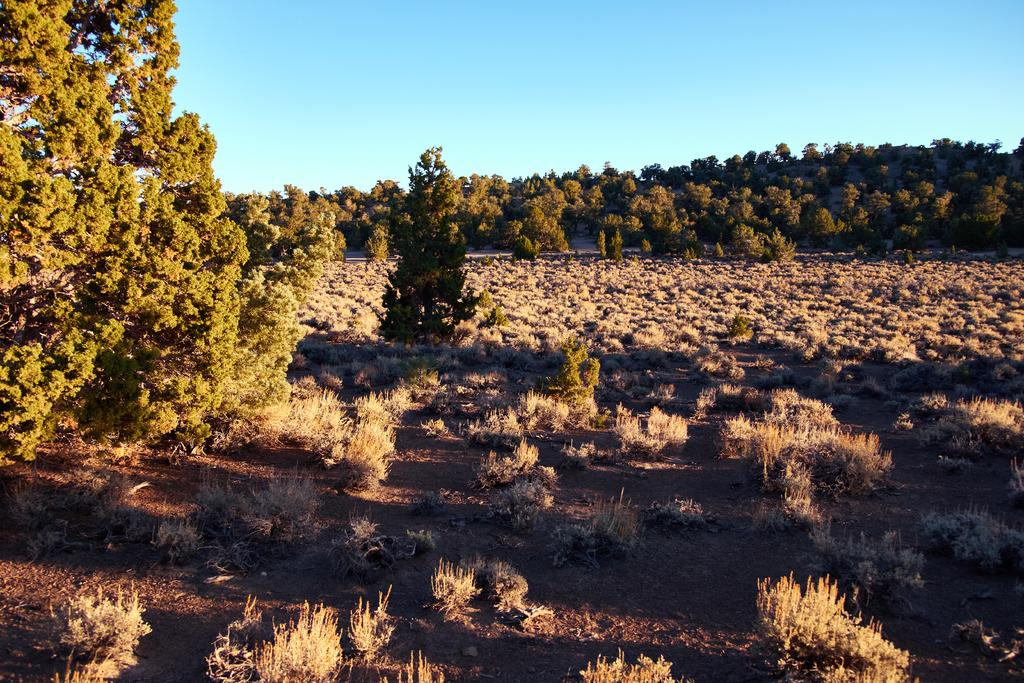What type of vegetation can be seen in the image? There is grass and trees in the image. What color is the sky in the image? The sky is blue in the image. What might be the weather condition during the time the image was taken? The image appears to be taken during a sunny day. Where might the image have been taken? The image appears to be taken in a forest. What type of chin can be seen in the image? There is no chin present in the image. What type of celery is growing in the image? There is no celery present in the image. 